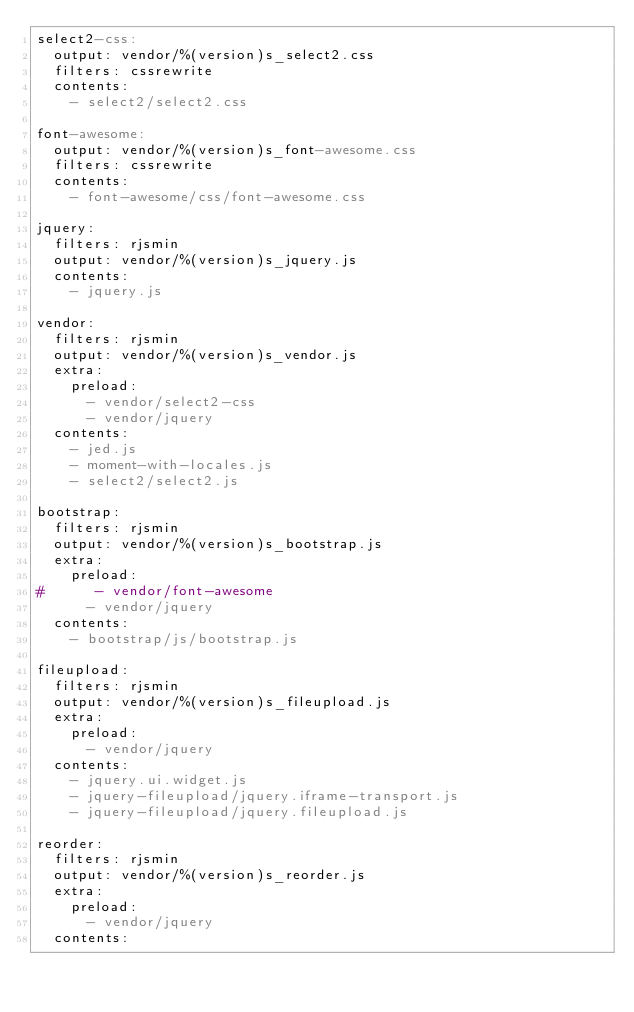Convert code to text. <code><loc_0><loc_0><loc_500><loc_500><_YAML_>select2-css:
  output: vendor/%(version)s_select2.css
  filters: cssrewrite
  contents:
    - select2/select2.css

font-awesome:
  output: vendor/%(version)s_font-awesome.css
  filters: cssrewrite
  contents:
    - font-awesome/css/font-awesome.css

jquery:
  filters: rjsmin
  output: vendor/%(version)s_jquery.js
  contents:
    - jquery.js

vendor:
  filters: rjsmin
  output: vendor/%(version)s_vendor.js
  extra:
    preload:
      - vendor/select2-css
      - vendor/jquery
  contents:
    - jed.js
    - moment-with-locales.js
    - select2/select2.js

bootstrap:
  filters: rjsmin
  output: vendor/%(version)s_bootstrap.js
  extra:
    preload:
#      - vendor/font-awesome
      - vendor/jquery
  contents:
    - bootstrap/js/bootstrap.js

fileupload:
  filters: rjsmin
  output: vendor/%(version)s_fileupload.js
  extra:
    preload:
      - vendor/jquery
  contents:
    - jquery.ui.widget.js
    - jquery-fileupload/jquery.iframe-transport.js
    - jquery-fileupload/jquery.fileupload.js

reorder:
  filters: rjsmin
  output: vendor/%(version)s_reorder.js
  extra:
    preload:
      - vendor/jquery
  contents:</code> 